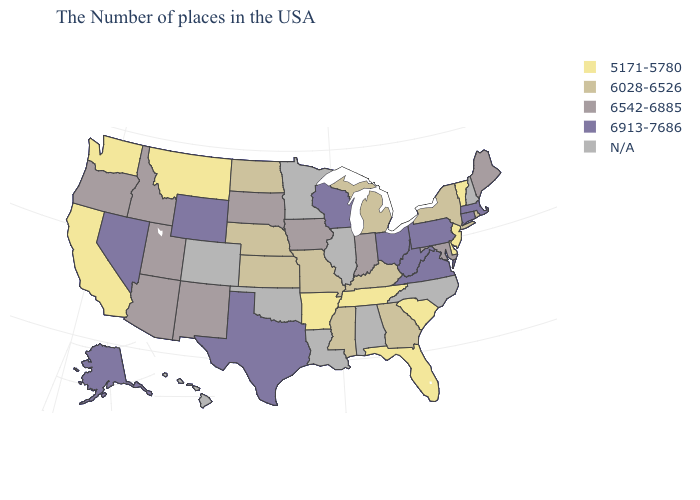What is the lowest value in the West?
Short answer required. 5171-5780. Name the states that have a value in the range 6028-6526?
Keep it brief. Rhode Island, New York, Georgia, Michigan, Kentucky, Mississippi, Missouri, Kansas, Nebraska, North Dakota. Among the states that border Nebraska , does Wyoming have the highest value?
Write a very short answer. Yes. Which states have the highest value in the USA?
Give a very brief answer. Massachusetts, Connecticut, Pennsylvania, Virginia, West Virginia, Ohio, Wisconsin, Texas, Wyoming, Nevada, Alaska. What is the value of Rhode Island?
Quick response, please. 6028-6526. Does Massachusetts have the highest value in the Northeast?
Keep it brief. Yes. How many symbols are there in the legend?
Quick response, please. 5. What is the highest value in the USA?
Quick response, please. 6913-7686. What is the lowest value in the South?
Write a very short answer. 5171-5780. Does the map have missing data?
Be succinct. Yes. What is the value of New York?
Be succinct. 6028-6526. What is the value of South Carolina?
Short answer required. 5171-5780. Name the states that have a value in the range 6913-7686?
Concise answer only. Massachusetts, Connecticut, Pennsylvania, Virginia, West Virginia, Ohio, Wisconsin, Texas, Wyoming, Nevada, Alaska. 